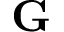<formula> <loc_0><loc_0><loc_500><loc_500>\mathbf G</formula> 